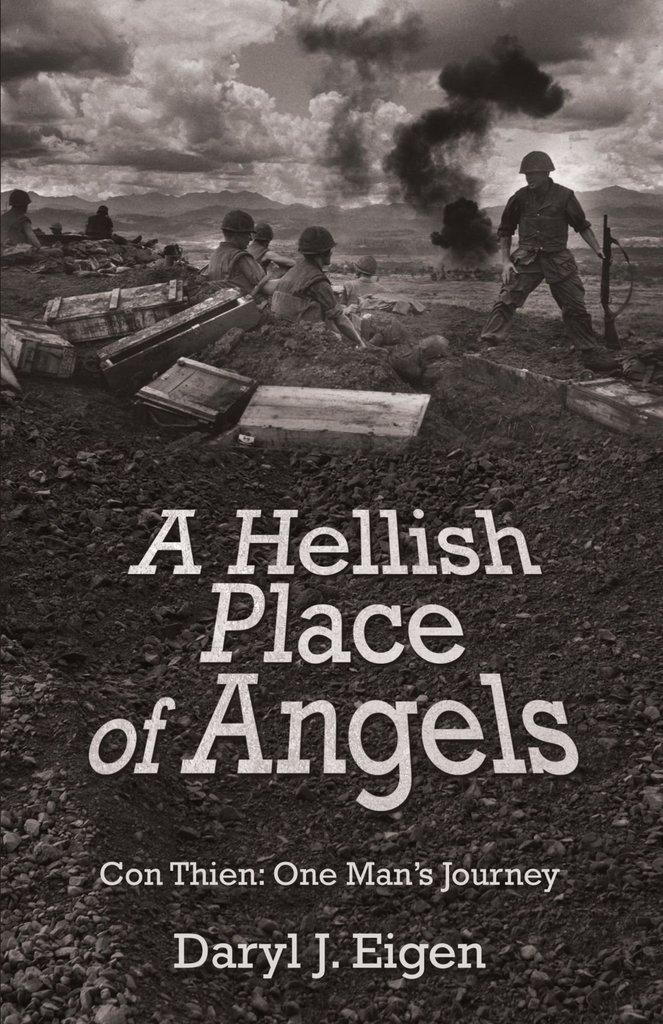<image>
Offer a succinct explanation of the picture presented. Book of war time A Hellish Place of Angels by Darly J. Eigen 